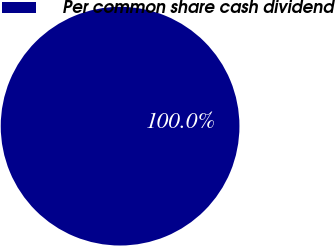<chart> <loc_0><loc_0><loc_500><loc_500><pie_chart><fcel>Per common share cash dividend<nl><fcel>100.0%<nl></chart> 